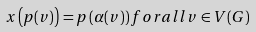Convert formula to latex. <formula><loc_0><loc_0><loc_500><loc_500>x \left ( p ( v ) \right ) = p \left ( \alpha ( v ) \right ) f o r a l l v \in V ( G )</formula> 